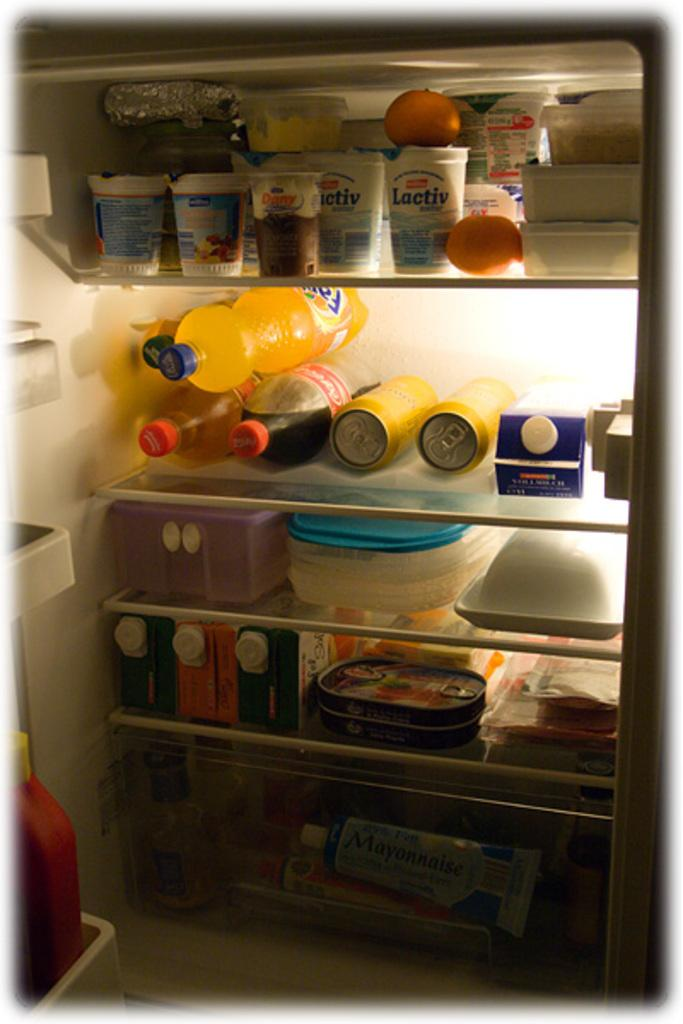<image>
Present a compact description of the photo's key features. open refrigerator that has fanta, coca-cola, lactiv, and other items in it 